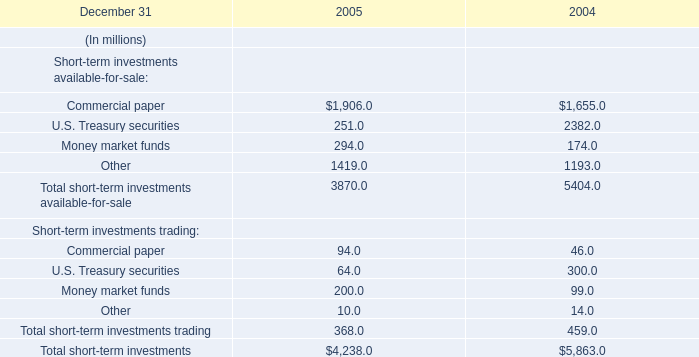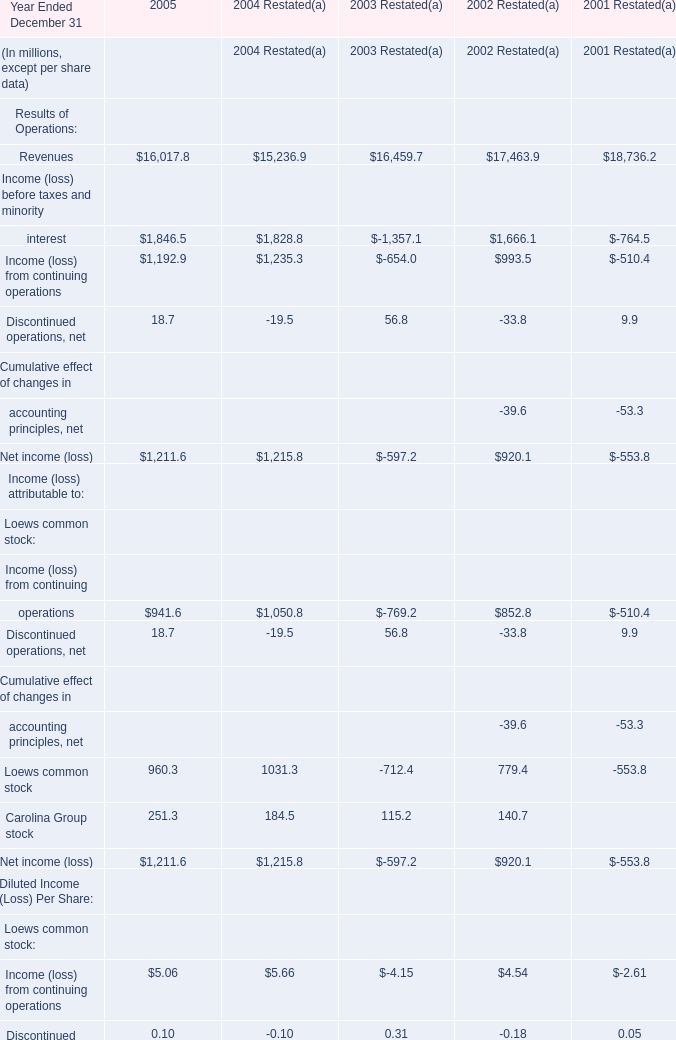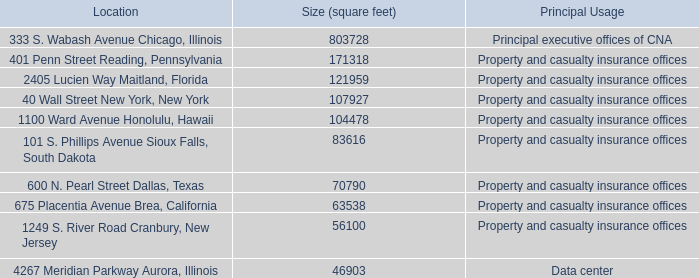What is the column number of the section where Revenues of Operations is the most? 
Answer: 5. 